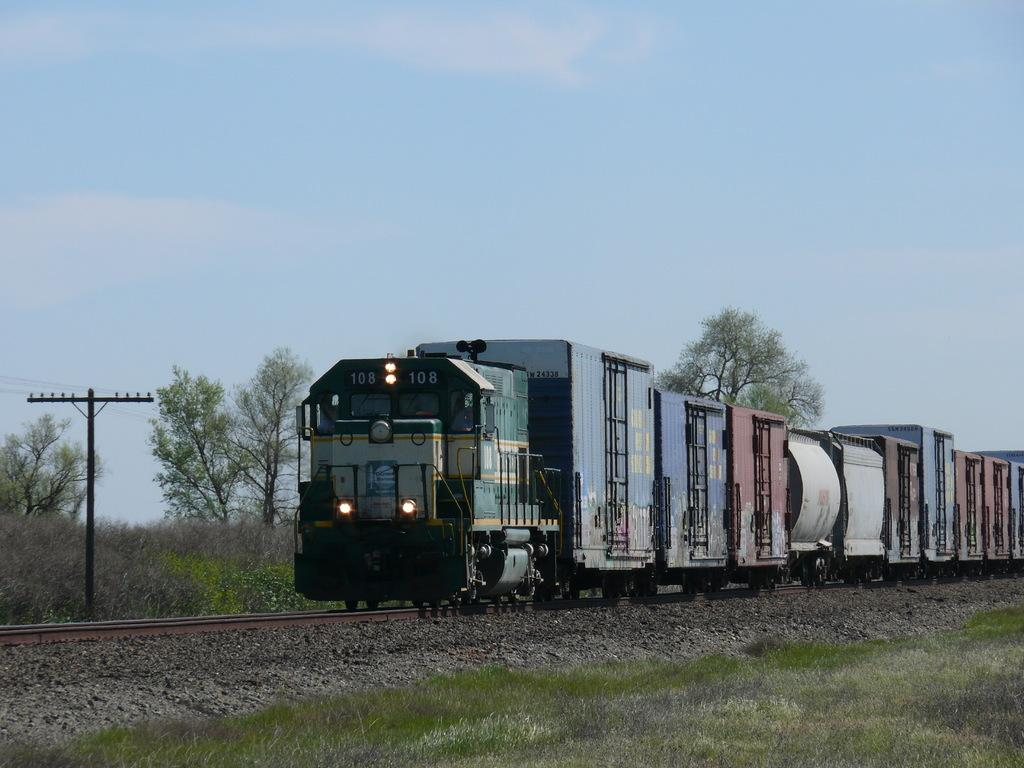What is the main subject of the image? The main subject of the image is a train on the railway track. What type of terrain can be seen in the image? Stones, grass, plants, and trees are visible in the image, indicating a natural terrain. What man-made structures are present in the image? There is an electric pole and electric cables in the image. What is visible in the sky in the image? The sky is visible in the image, with clouds present. What type of teeth can be seen on the train in the image? There are no teeth present on the train in the image; it is a vehicle and does not have teeth. 